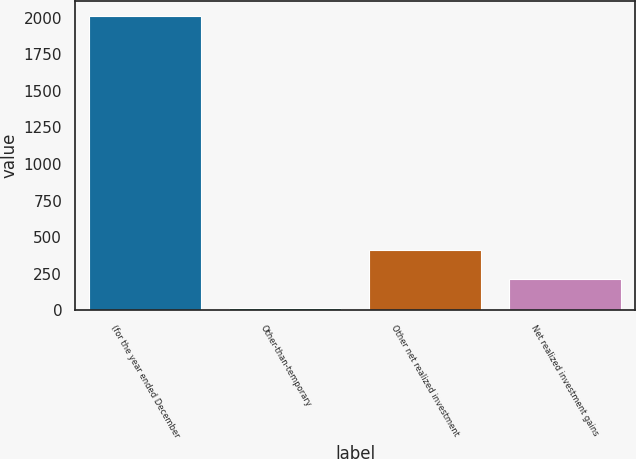Convert chart to OTSL. <chart><loc_0><loc_0><loc_500><loc_500><bar_chart><fcel>(for the year ended December<fcel>Other-than-temporary<fcel>Other net realized investment<fcel>Net realized investment gains<nl><fcel>2012<fcel>15<fcel>414.4<fcel>214.7<nl></chart> 